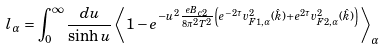<formula> <loc_0><loc_0><loc_500><loc_500>l _ { \alpha } = \int _ { 0 } ^ { \infty } \frac { d u } { \sinh u } \left \langle 1 - e ^ { - u ^ { 2 } \frac { e B _ { c 2 } } { 8 \pi ^ { 2 } T ^ { 2 } } \left ( e ^ { - 2 \tau } v _ { F 1 , \alpha } ^ { 2 } ( \hat { k } ) + e ^ { 2 \tau } v _ { F 2 , \alpha } ^ { 2 } ( \hat { k } ) \right ) } \right \rangle _ { \alpha }</formula> 